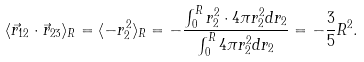Convert formula to latex. <formula><loc_0><loc_0><loc_500><loc_500>\langle \vec { r } _ { 1 2 } \cdot \vec { r } _ { 2 3 } \rangle _ { R } = \langle - r _ { 2 } ^ { 2 } \rangle _ { R } = - \frac { \int _ { 0 } ^ { R } r _ { 2 } ^ { 2 } \cdot 4 \pi r _ { 2 } ^ { 2 } d r _ { 2 } } { \int _ { 0 } ^ { R } 4 \pi r _ { 2 } ^ { 2 } d r _ { 2 } } = - \frac { 3 } { 5 } R ^ { 2 } .</formula> 